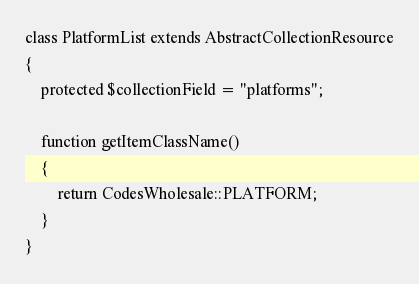<code> <loc_0><loc_0><loc_500><loc_500><_PHP_>class PlatformList extends AbstractCollectionResource
{
    protected $collectionField = "platforms";

    function getItemClassName()
    {
        return CodesWholesale::PLATFORM;
    }
}</code> 